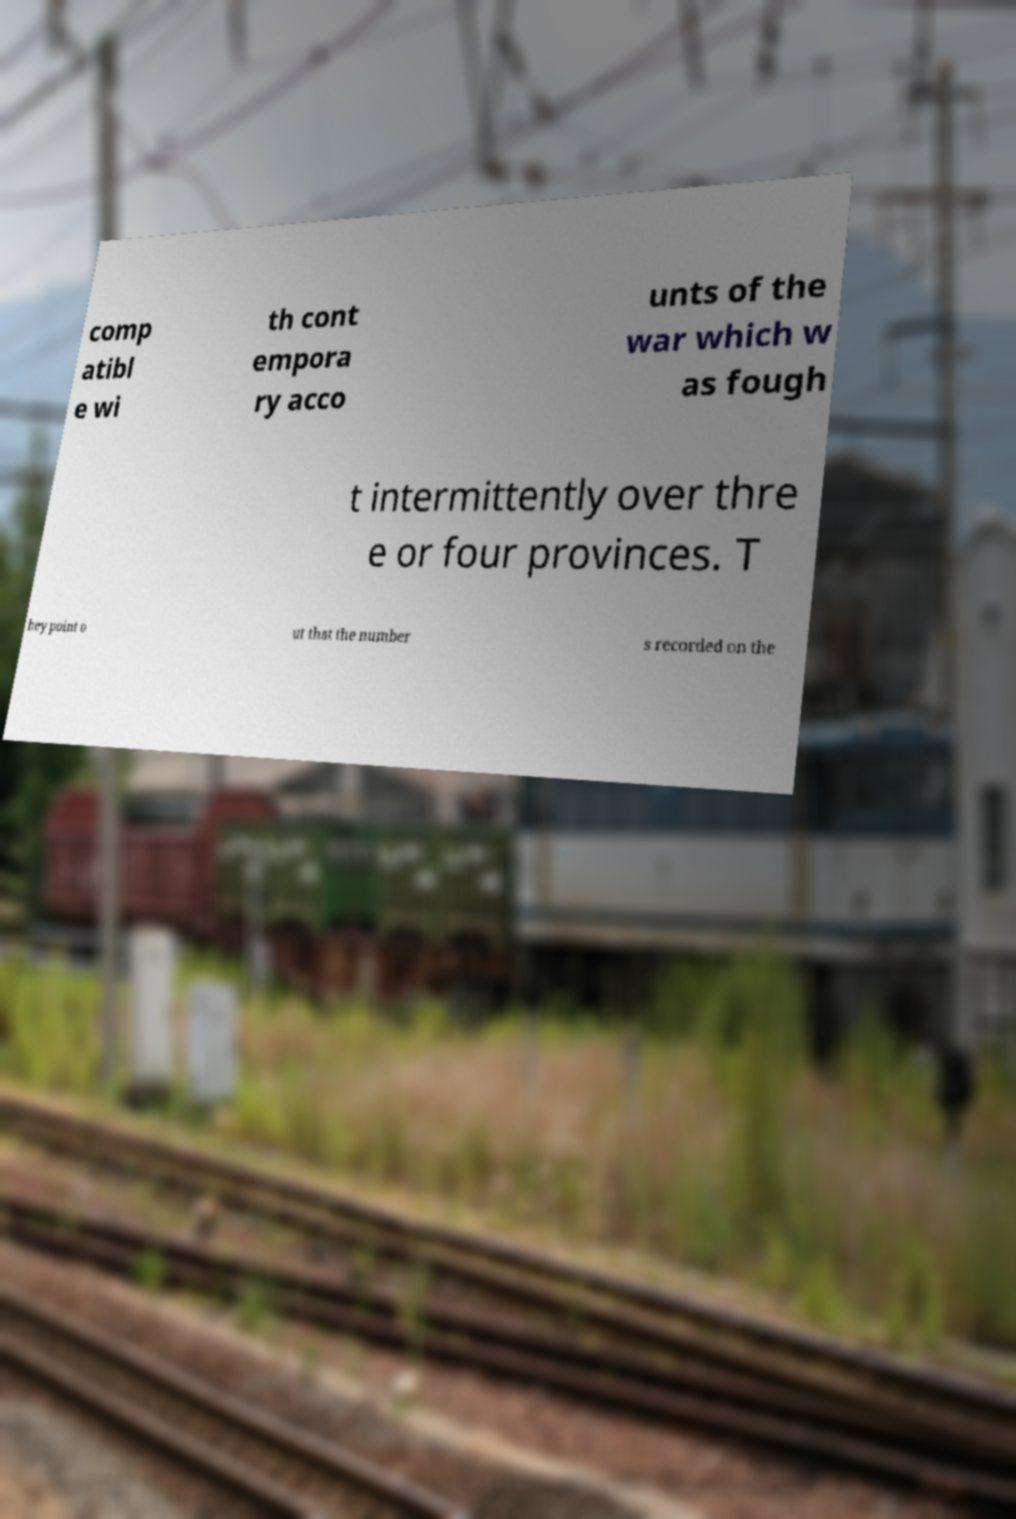Can you accurately transcribe the text from the provided image for me? comp atibl e wi th cont empora ry acco unts of the war which w as fough t intermittently over thre e or four provinces. T hey point o ut that the number s recorded on the 